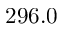<formula> <loc_0><loc_0><loc_500><loc_500>2 9 6 . 0</formula> 